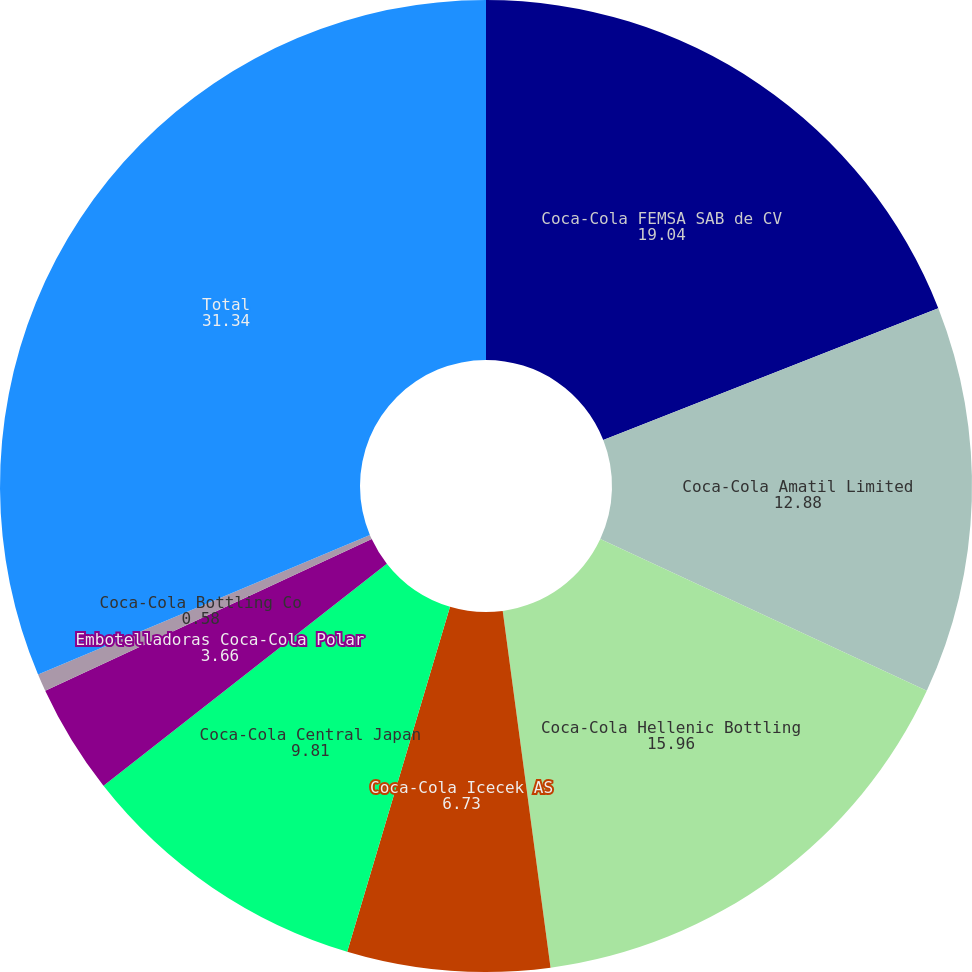<chart> <loc_0><loc_0><loc_500><loc_500><pie_chart><fcel>Coca-Cola FEMSA SAB de CV<fcel>Coca-Cola Amatil Limited<fcel>Coca-Cola Hellenic Bottling<fcel>Coca-Cola Icecek AS<fcel>Coca-Cola Central Japan<fcel>Embotelladoras Coca-Cola Polar<fcel>Coca-Cola Bottling Co<fcel>Total<nl><fcel>19.04%<fcel>12.88%<fcel>15.96%<fcel>6.73%<fcel>9.81%<fcel>3.66%<fcel>0.58%<fcel>31.34%<nl></chart> 